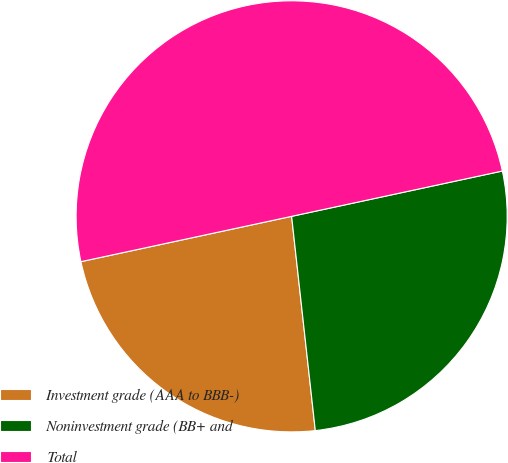Convert chart to OTSL. <chart><loc_0><loc_0><loc_500><loc_500><pie_chart><fcel>Investment grade (AAA to BBB-)<fcel>Noninvestment grade (BB+ and<fcel>Total<nl><fcel>23.38%<fcel>26.62%<fcel>50.0%<nl></chart> 